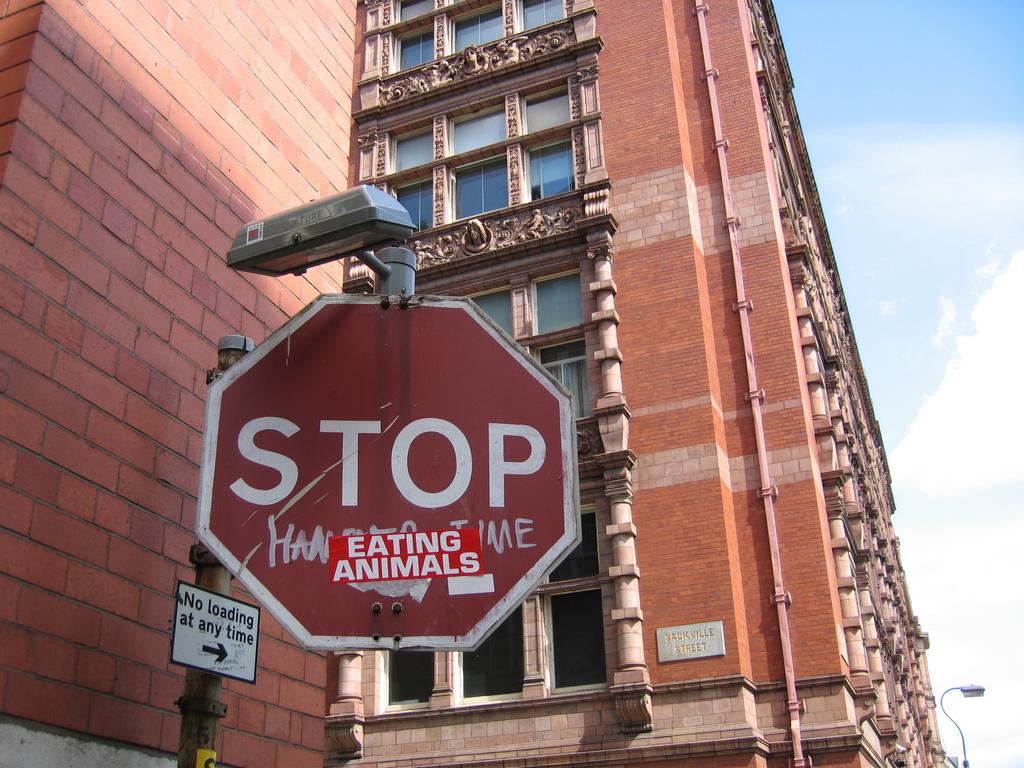What kind of street sign is this?
Offer a very short reply. Stop sign. 